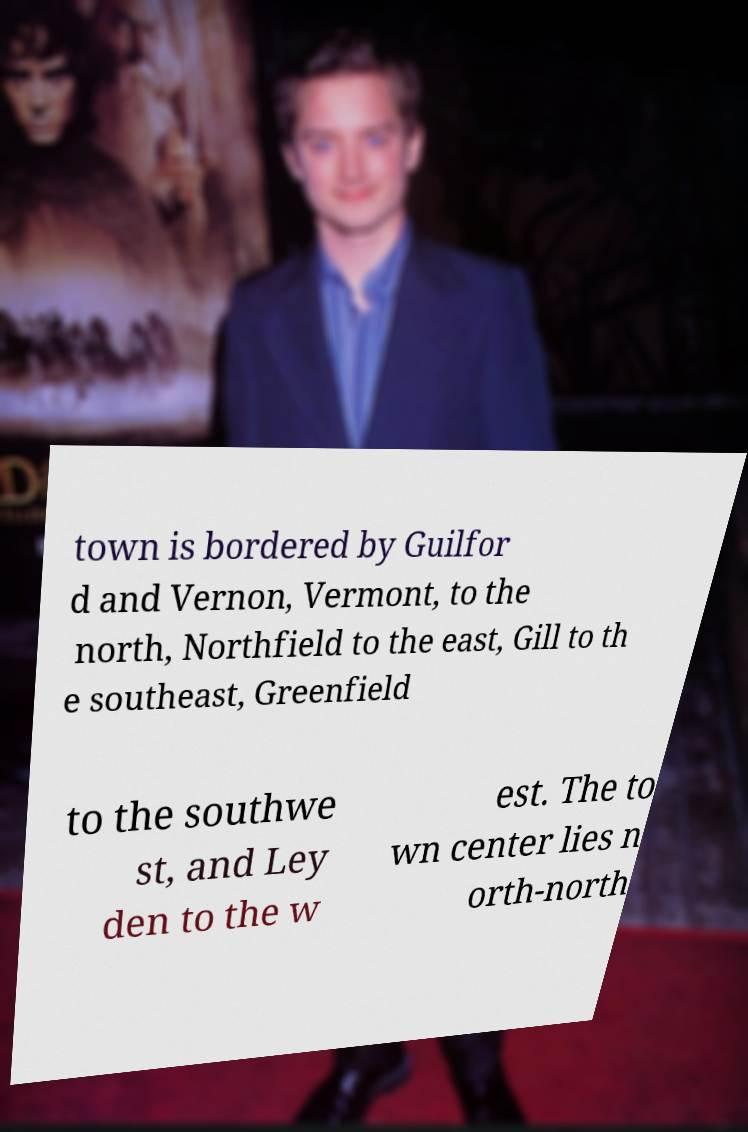Could you assist in decoding the text presented in this image and type it out clearly? town is bordered by Guilfor d and Vernon, Vermont, to the north, Northfield to the east, Gill to th e southeast, Greenfield to the southwe st, and Ley den to the w est. The to wn center lies n orth-north 